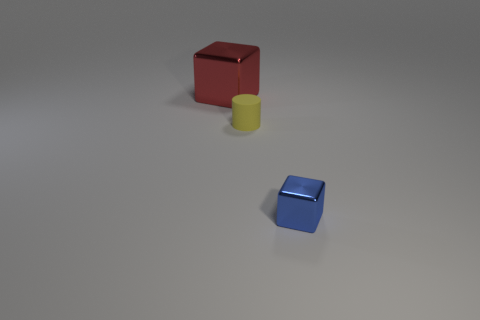Is there any other thing that is the same size as the red shiny cube?
Make the answer very short. No. There is a cube that is in front of the cube to the left of the cube right of the red object; what is its material?
Keep it short and to the point. Metal. Is the shape of the shiny object right of the red thing the same as  the large thing?
Your response must be concise. Yes. What is the material of the cube in front of the tiny yellow thing?
Ensure brevity in your answer.  Metal. How many rubber objects are yellow cylinders or cubes?
Give a very brief answer. 1. Are there any blue blocks of the same size as the yellow rubber cylinder?
Keep it short and to the point. Yes. Are there more small cubes to the right of the cylinder than large yellow metal objects?
Make the answer very short. Yes. How many big objects are cylinders or green spheres?
Provide a succinct answer. 0. How many other blue things have the same shape as the tiny rubber object?
Provide a succinct answer. 0. What is the material of the cube that is on the left side of the shiny block that is to the right of the large cube?
Provide a succinct answer. Metal. 